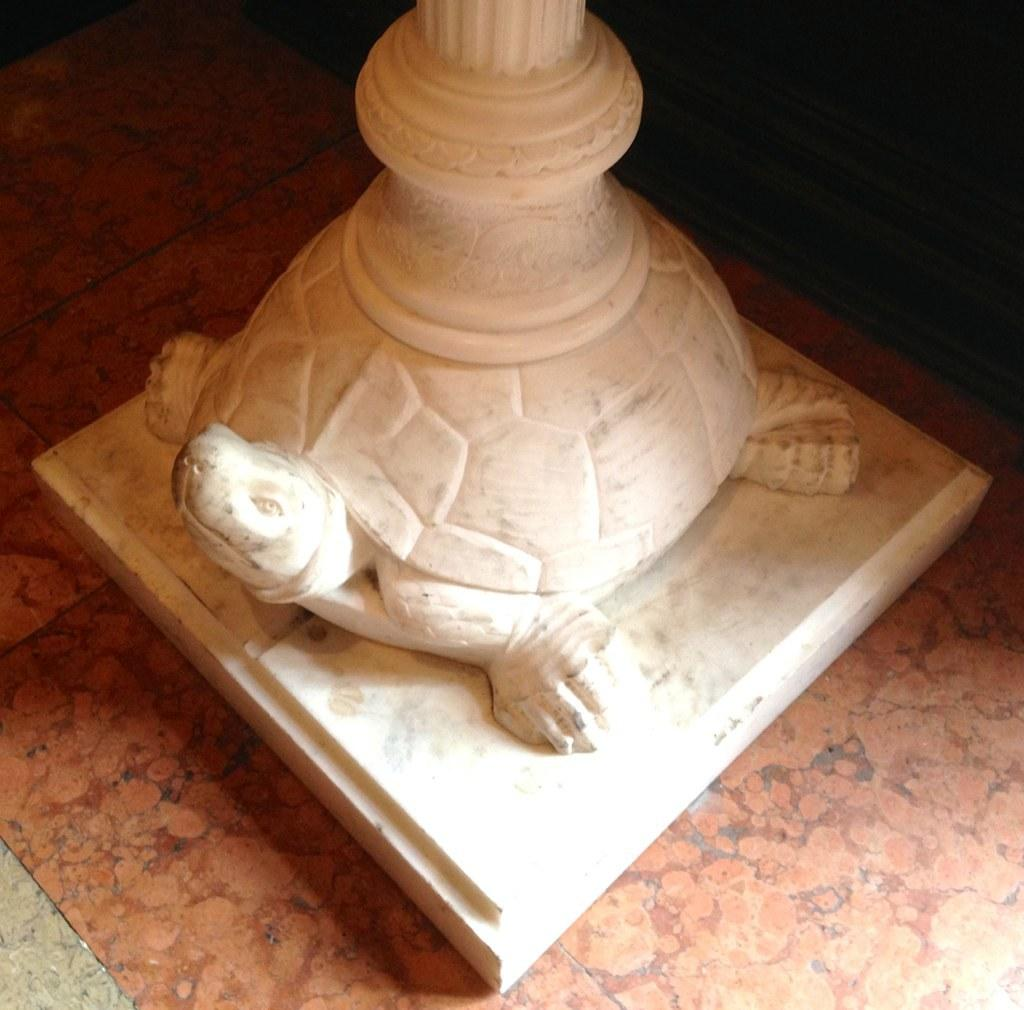What is the main subject of the image? The main subject of the image is a statue of a tortoise on a platform. Can you describe the statue's location in the image? The statue of the tortoise is on a platform in the image. How does the deer maintain the boundary in the image? There is no deer present in the image, and therefore no such activity can be observed. 